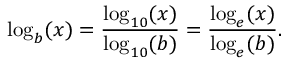<formula> <loc_0><loc_0><loc_500><loc_500>\log _ { b } ( x ) = { \frac { \log _ { 1 0 } ( x ) } { \log _ { 1 0 } ( b ) } } = { \frac { \log _ { e } ( x ) } { \log _ { e } ( b ) } } .</formula> 